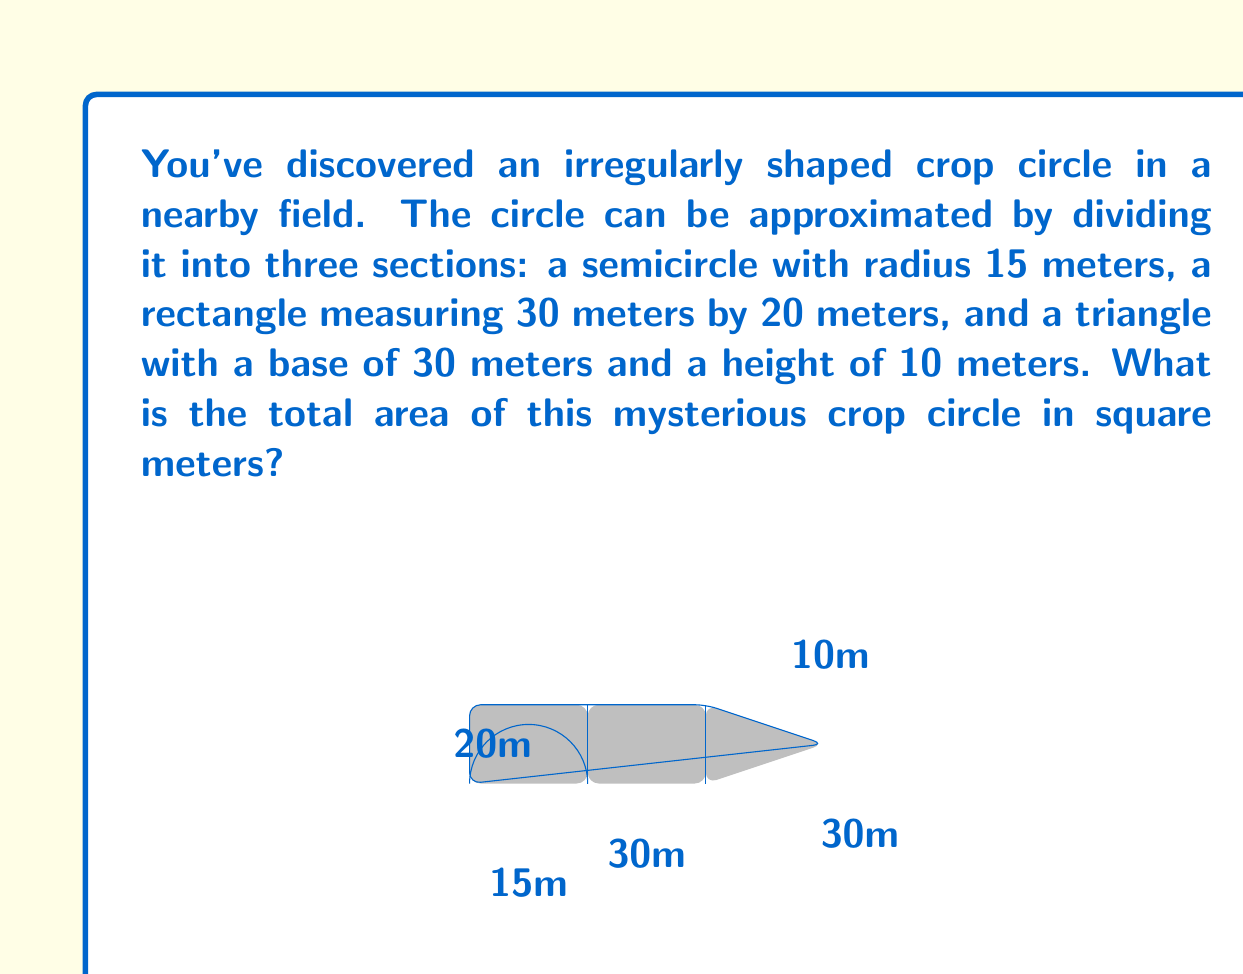Give your solution to this math problem. To find the total area of the crop circle, we need to calculate the areas of each section and sum them up:

1. Area of the semicircle:
   The formula for the area of a circle is $A = \pi r^2$. For a semicircle, we use half of this.
   $$A_{\text{semicircle}} = \frac{1}{2} \pi r^2 = \frac{1}{2} \pi (15^2) = \frac{1}{2} \pi (225) = 112.5\pi \approx 353.43 \text{ m}^2$$

2. Area of the rectangle:
   $$A_{\text{rectangle}} = l \times w = 30 \times 20 = 600 \text{ m}^2$$

3. Area of the triangle:
   $$A_{\text{triangle}} = \frac{1}{2} \times \text{base} \times \text{height} = \frac{1}{2} \times 30 \times 10 = 150 \text{ m}^2$$

4. Total area:
   $$A_{\text{total}} = A_{\text{semicircle}} + A_{\text{rectangle}} + A_{\text{triangle}}$$
   $$A_{\text{total}} = 353.43 + 600 + 150 = 1103.43 \text{ m}^2$$

Therefore, the total area of the crop circle is approximately 1103.43 square meters.
Answer: $1103.43 \text{ m}^2$ 